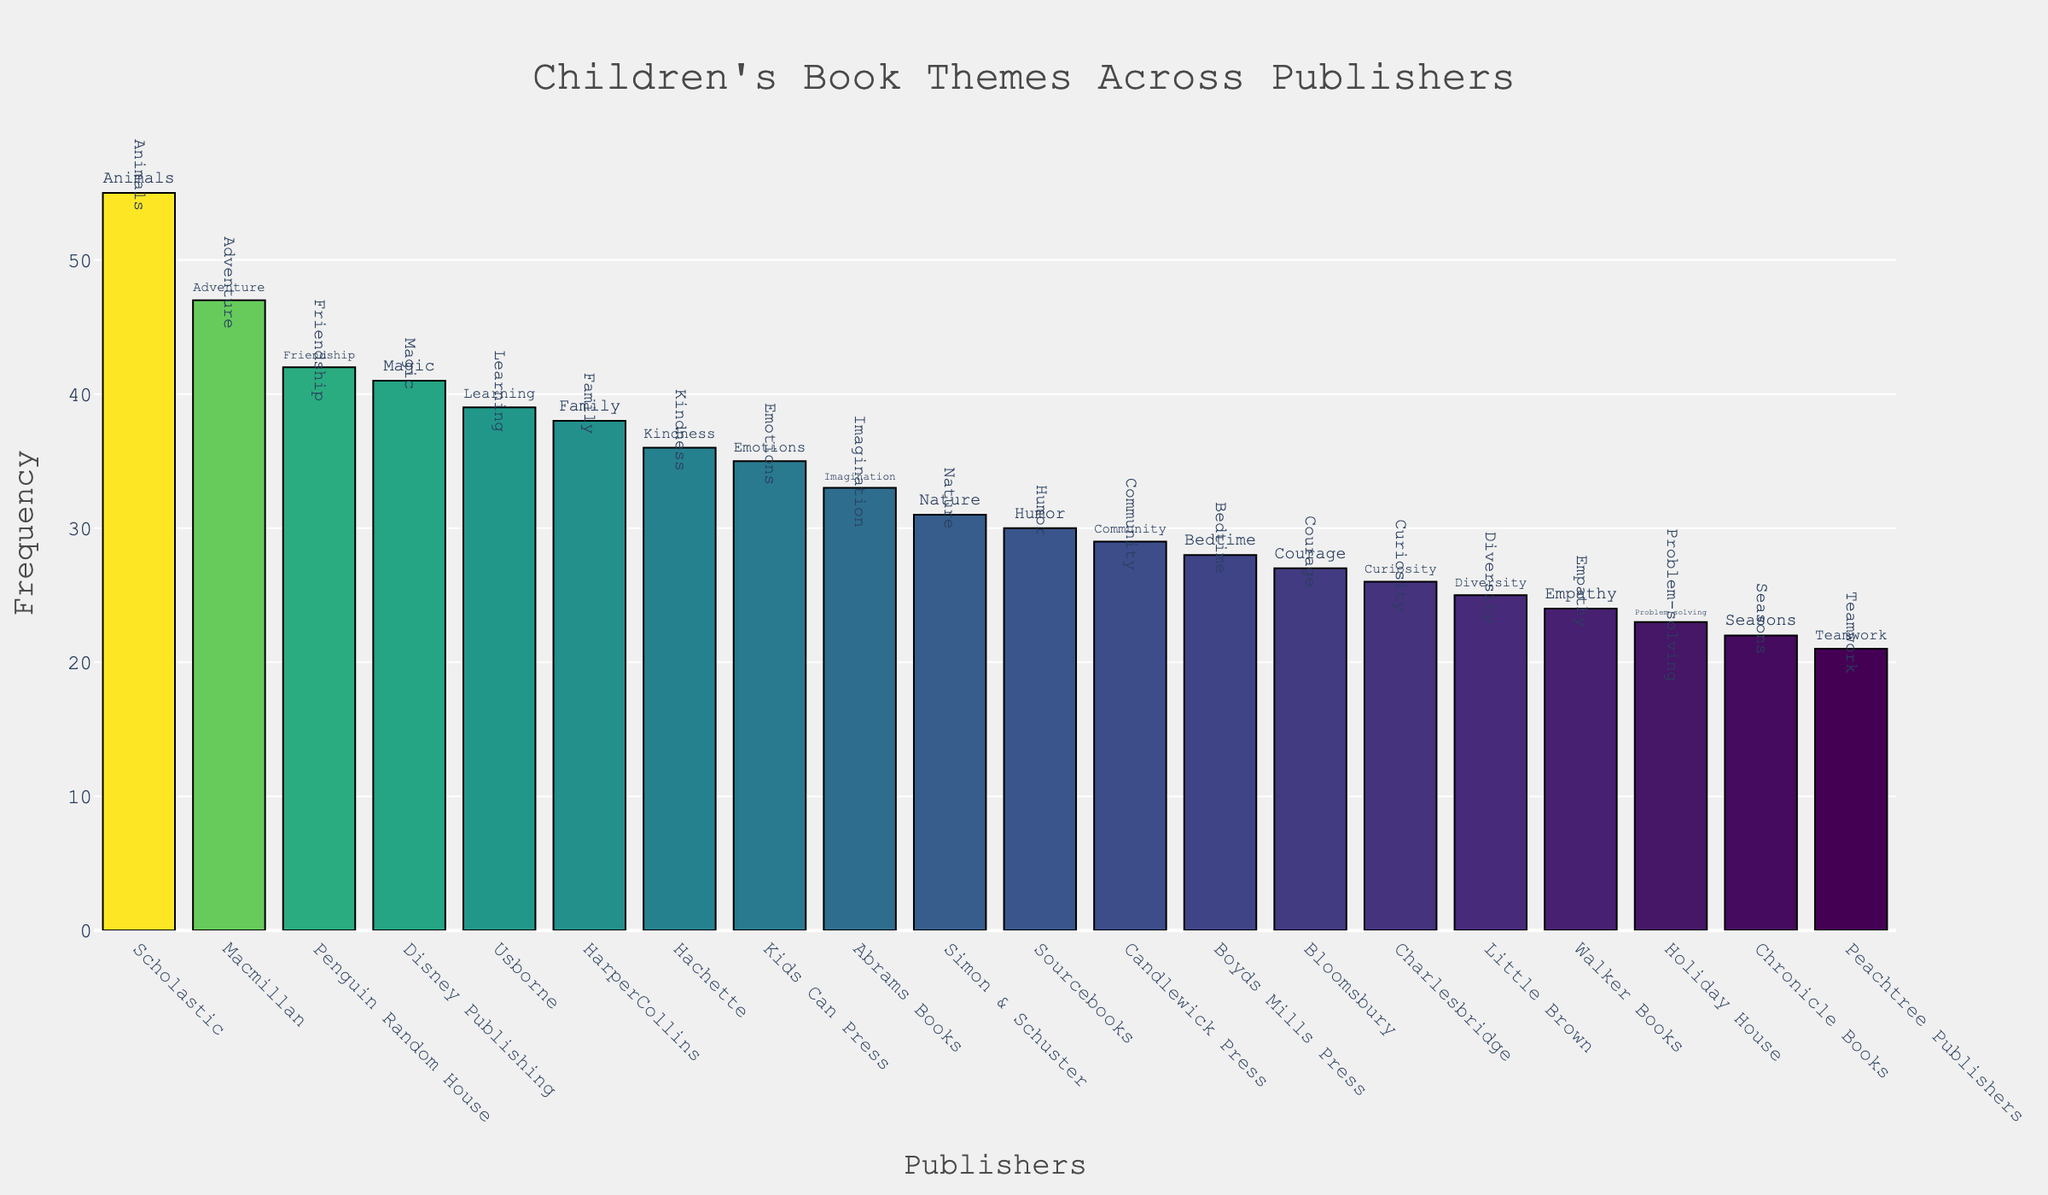How many publishers are represented in the figure? Count the number of unique publisher names listed along the x-axis.
Answer: 20 What theme has the highest frequency, and which publisher is it associated with? Identify the tallest bar in the plot, which corresponds to the highest frequency, and check the publisher associated with it.
Answer: Animals, Scholastic What is the difference in frequency between the themes with the highest and lowest values? Identify the tallest and shortest bars in the plot, then subtract the frequency of the shortest bar from the frequency of the tallest bar.
Answer: 34 Which theme appears most often for Macmillan? Look for the annotation text next to the bar for Macmillan along the x-axis.
Answer: Adventure Does the theme "Magic" appear more frequently than "Family"? Compare the heights of the bars annotated with "Magic" and "Family" and determine which is taller.
Answer: Yes, Magic (41) is more frequent than Family (38) What is the average frequency of themes published by Penguin Random House, HarperCollins, and Simon & Schuster? Find the frequencies for the three specified publishers, add them together, and divide by 3. This is (42 for Penguin Random House + 38 for HarperCollins + 31 for Simon & Schuster) / 3.
Answer: 37 Which publishers have a frequency of themes greater than 40? Identify bars with heights over 40 units and note the associated publishers.
Answer: Penguin Random House, Macmillan, Disney Publishing, Scholastic How many themes have a frequency between 30 and 40? Count the number of bars with a height between 30 and 40 units along the y-axis.
Answer: 5 What are the themes for the publishers with the top three frequencies? Check the annotations for the top three tallest bars.
Answer: Animals (Scholastic), Adventure (Macmillan), Friendship (Penguin Random House) Which publisher has the theme "Imagination," and what is its frequency? Locate the label "Imagination" along the x-axis and note the corresponding publisher and height of the bar.
Answer: Abrams Books, 33 